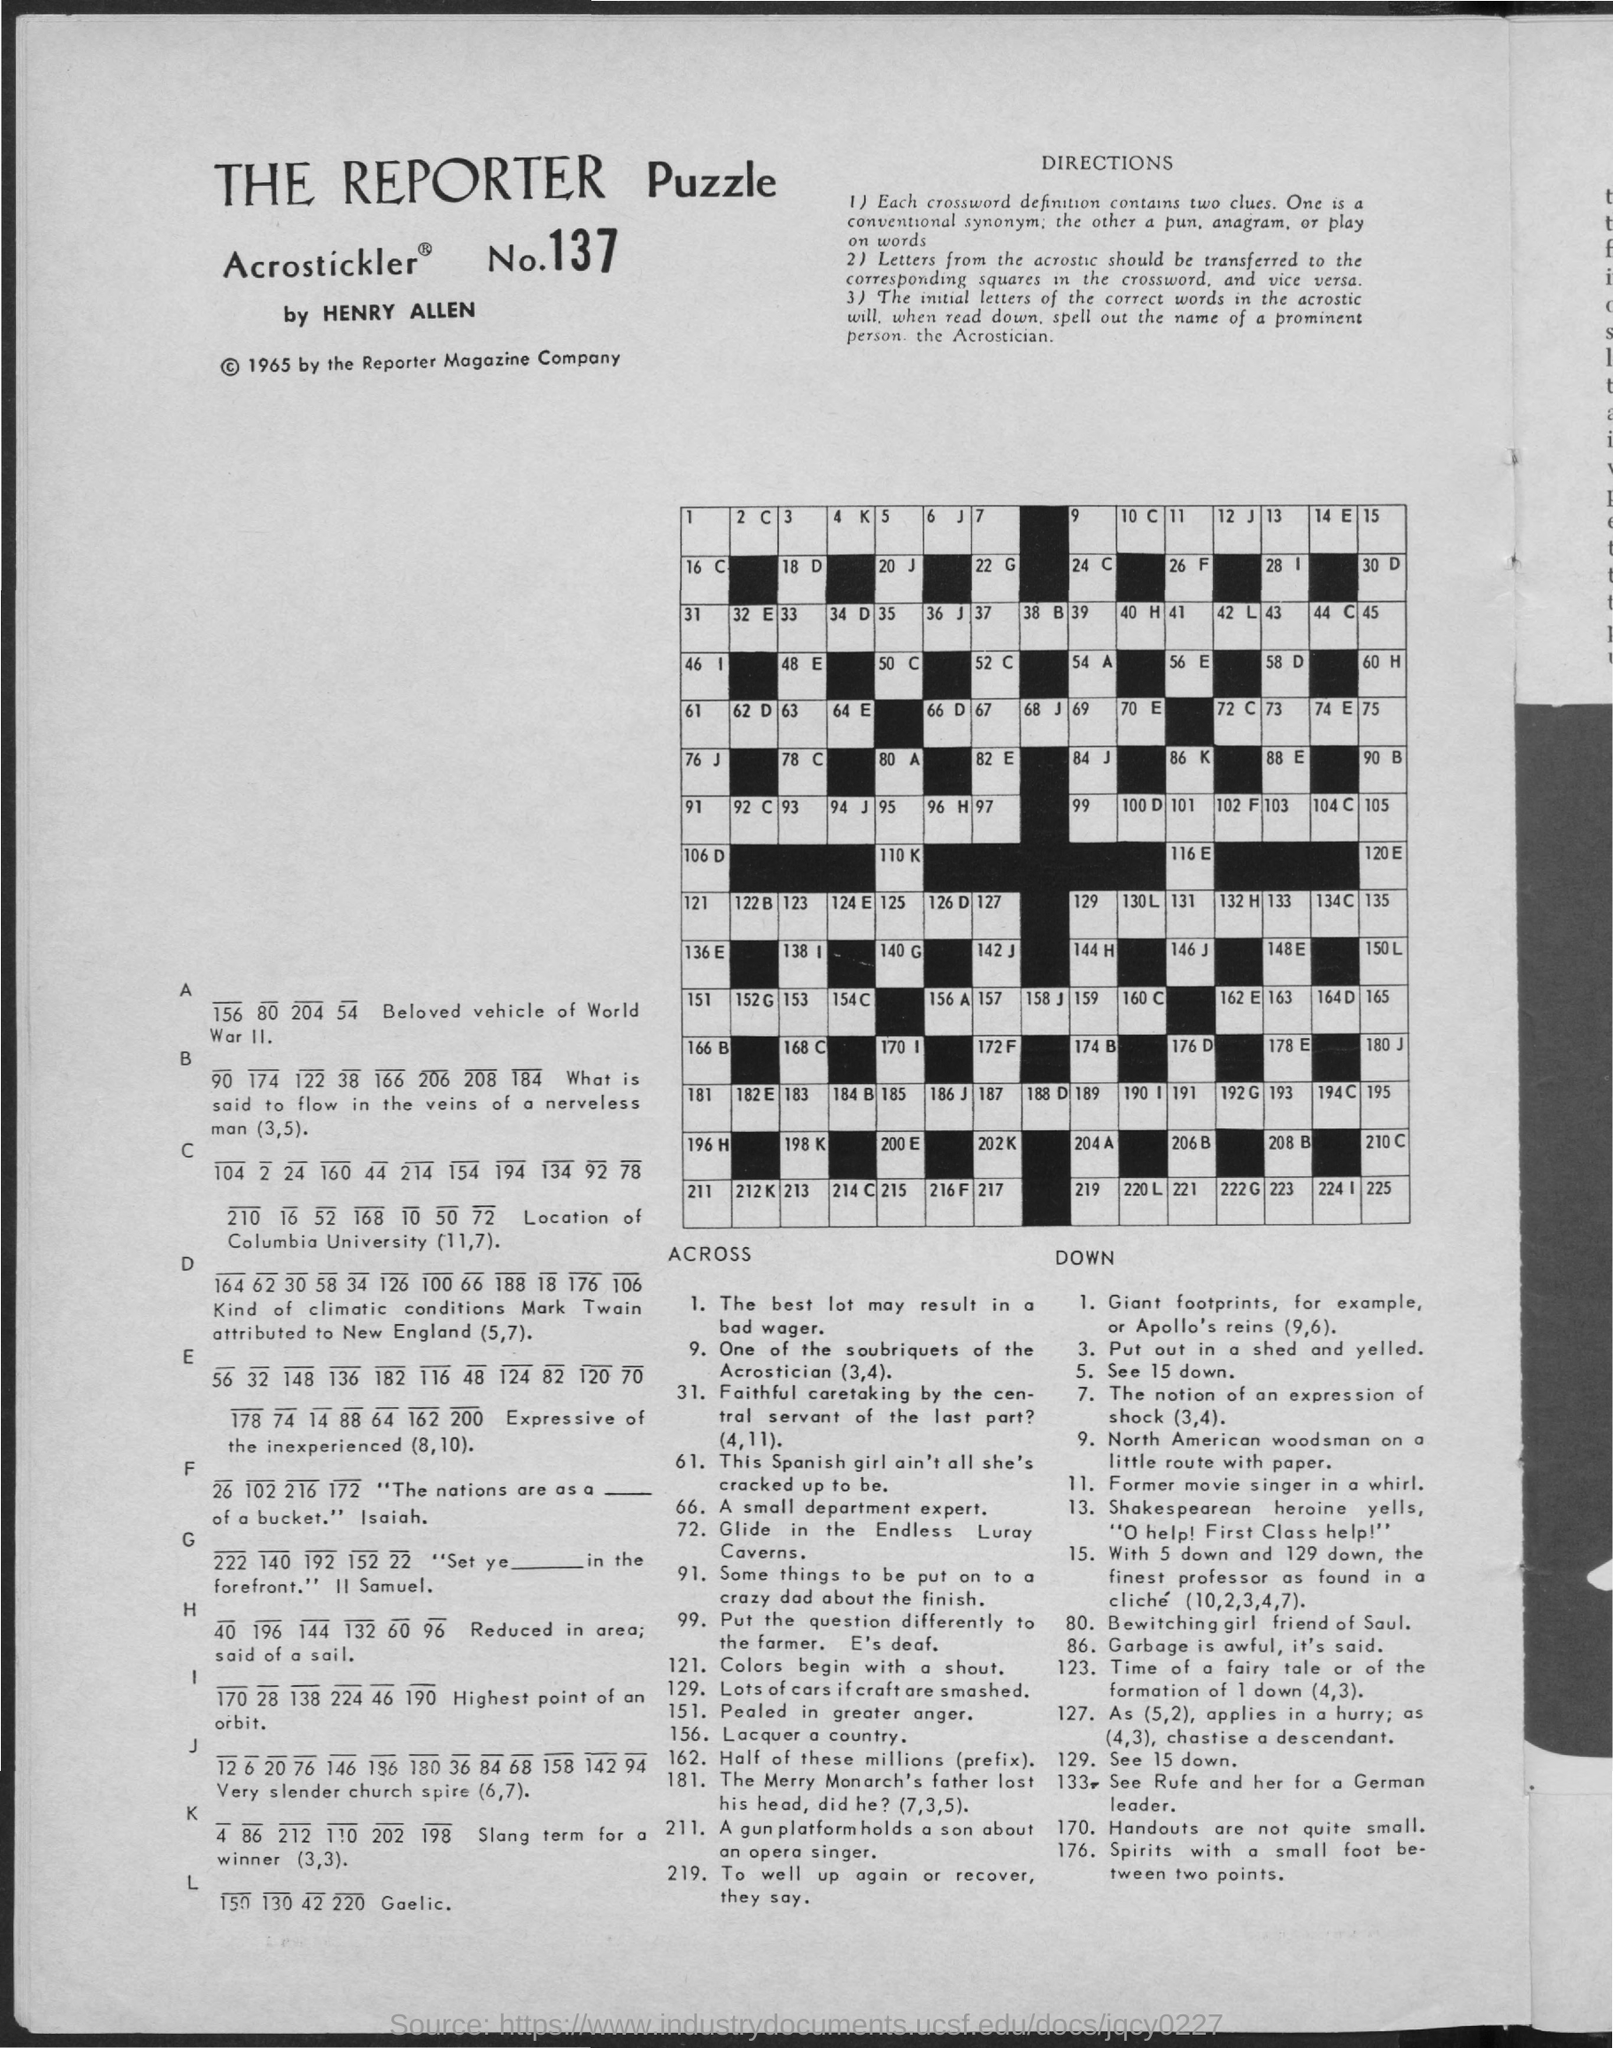Point out several critical features in this image. The Reporter Puzzle is copyrighted by The Reporter Magazine Company. The Reporter Magazine Company registered the puzzle in 1965. The Reporter Puzzle has 137 pieces. 